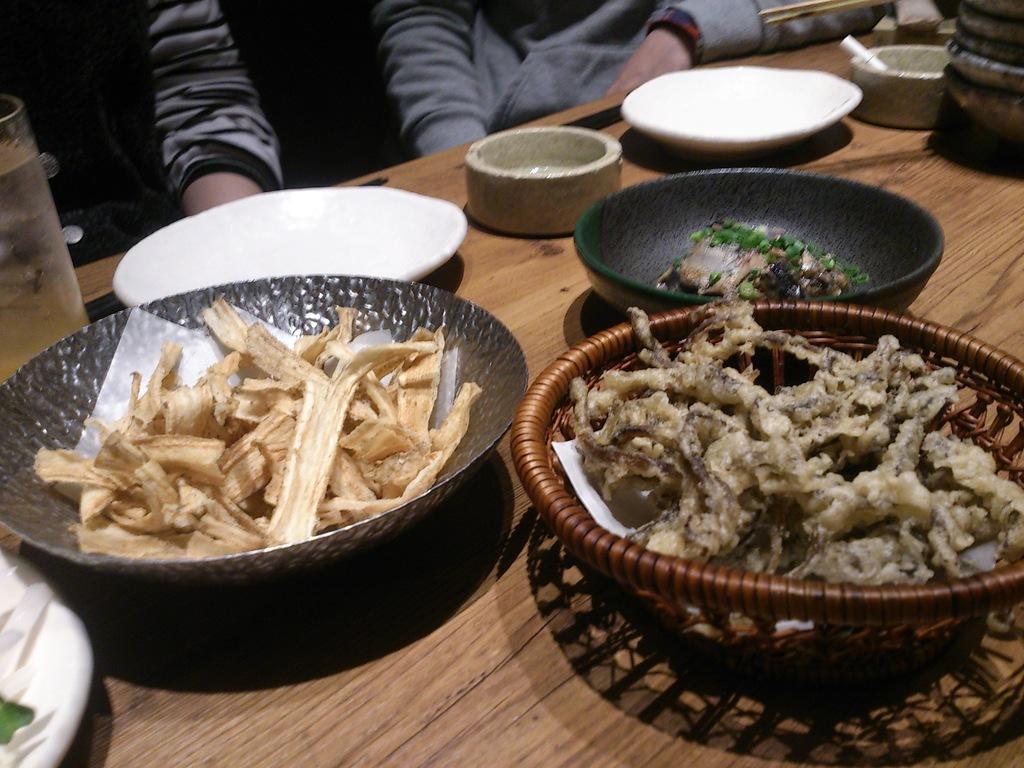Please provide a concise description of this image. In this picture there is a table in the center of the image, on which there are plates, bowls, and food items on it and there are people those who are sitting at the top side of the image. 